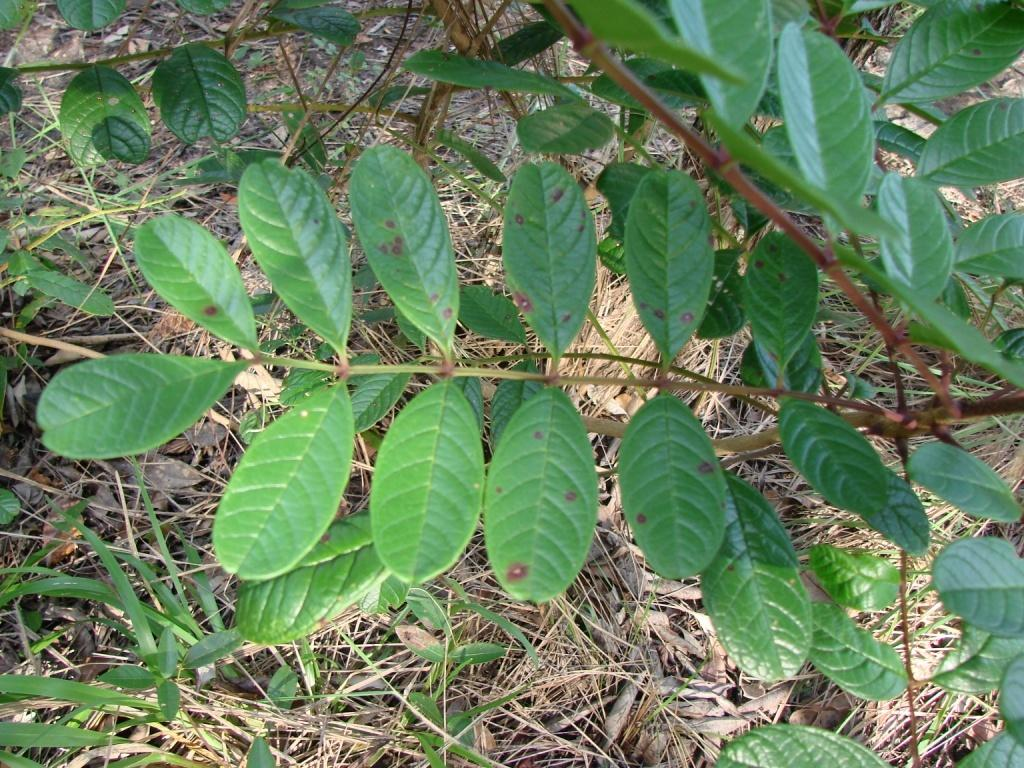What type of living organisms can be seen in the image? Plants can be seen in the image. What can be seen in the background of the image? There is dried grass in the background of the image. What type of wing can be seen on the dolls in the image? There are no dolls or wings present in the image. 